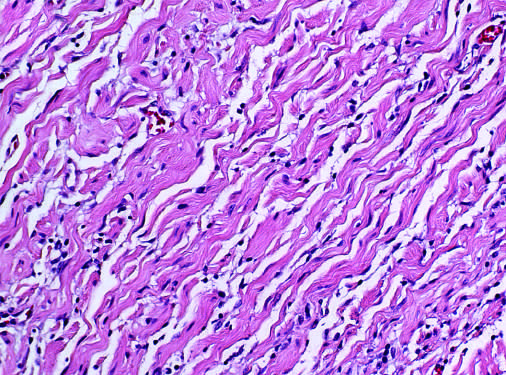what are seen to consist of bland spindle cells admixed with wavy collagen bundles likened to carrot shavings?
Answer the question using a single word or phrase. Infiltrating tumor cells 